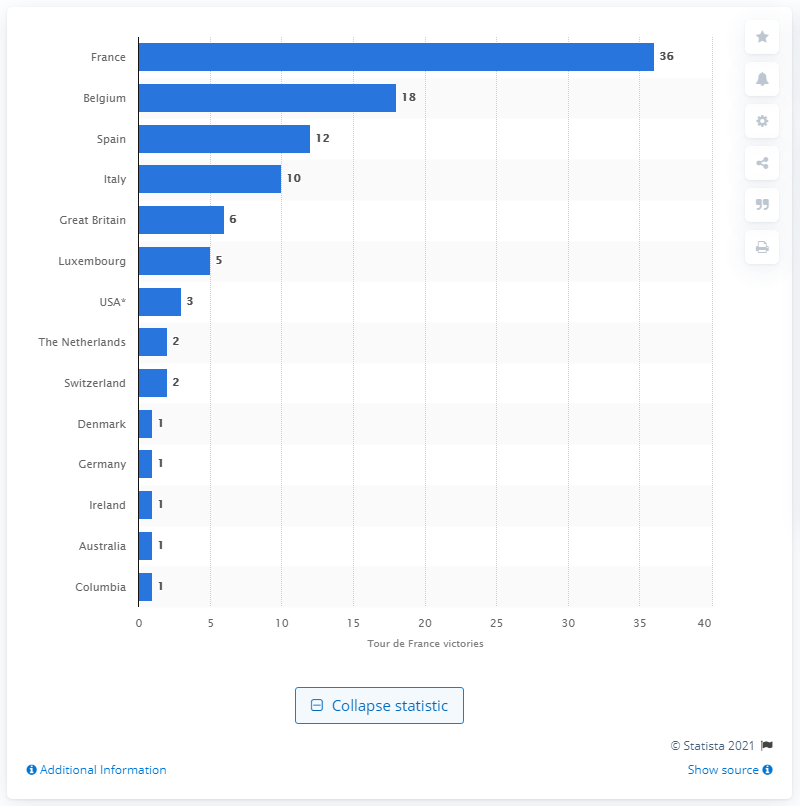Mention a couple of crucial points in this snapshot. The winner of the Tour de France originated from Italy. 